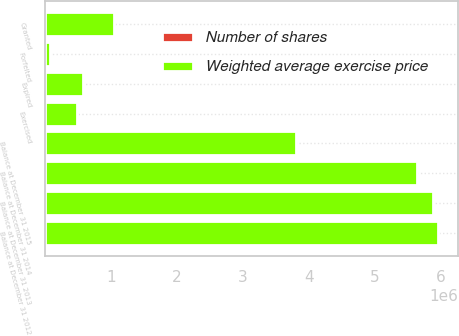Convert chart to OTSL. <chart><loc_0><loc_0><loc_500><loc_500><stacked_bar_chart><ecel><fcel>Balance at December 31 2012<fcel>Granted<fcel>Exercised<fcel>Expired<fcel>Forfeited<fcel>Balance at December 31 2013<fcel>Balance at December 31 2014<fcel>Balance at December 31 2015<nl><fcel>Weighted average exercise price<fcel>5.96232e+06<fcel>1.04778e+06<fcel>488479<fcel>574157<fcel>72880<fcel>5.87459e+06<fcel>5.6305e+06<fcel>3.8041e+06<nl><fcel>Number of shares<fcel>38.87<fcel>27.41<fcel>20.11<fcel>70.12<fcel>22.25<fcel>35.54<fcel>31.6<fcel>27.3<nl></chart> 